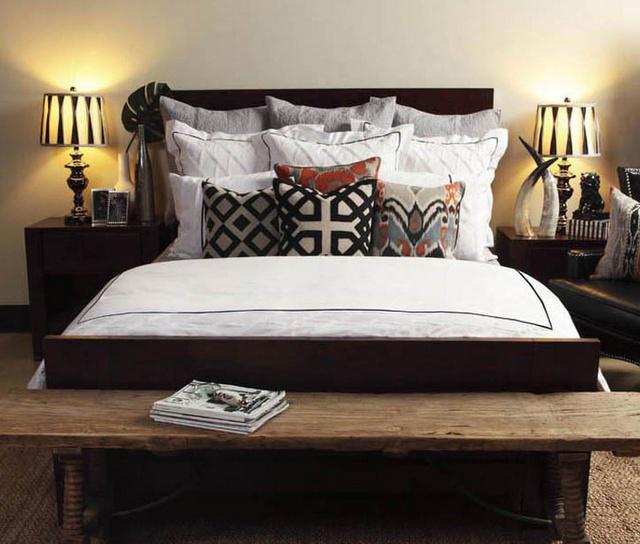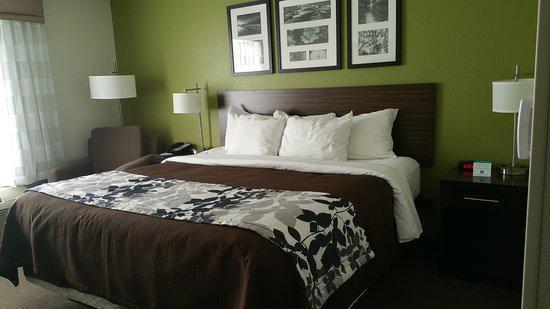The first image is the image on the left, the second image is the image on the right. Assess this claim about the two images: "both bedframes are brown". Correct or not? Answer yes or no. Yes. 